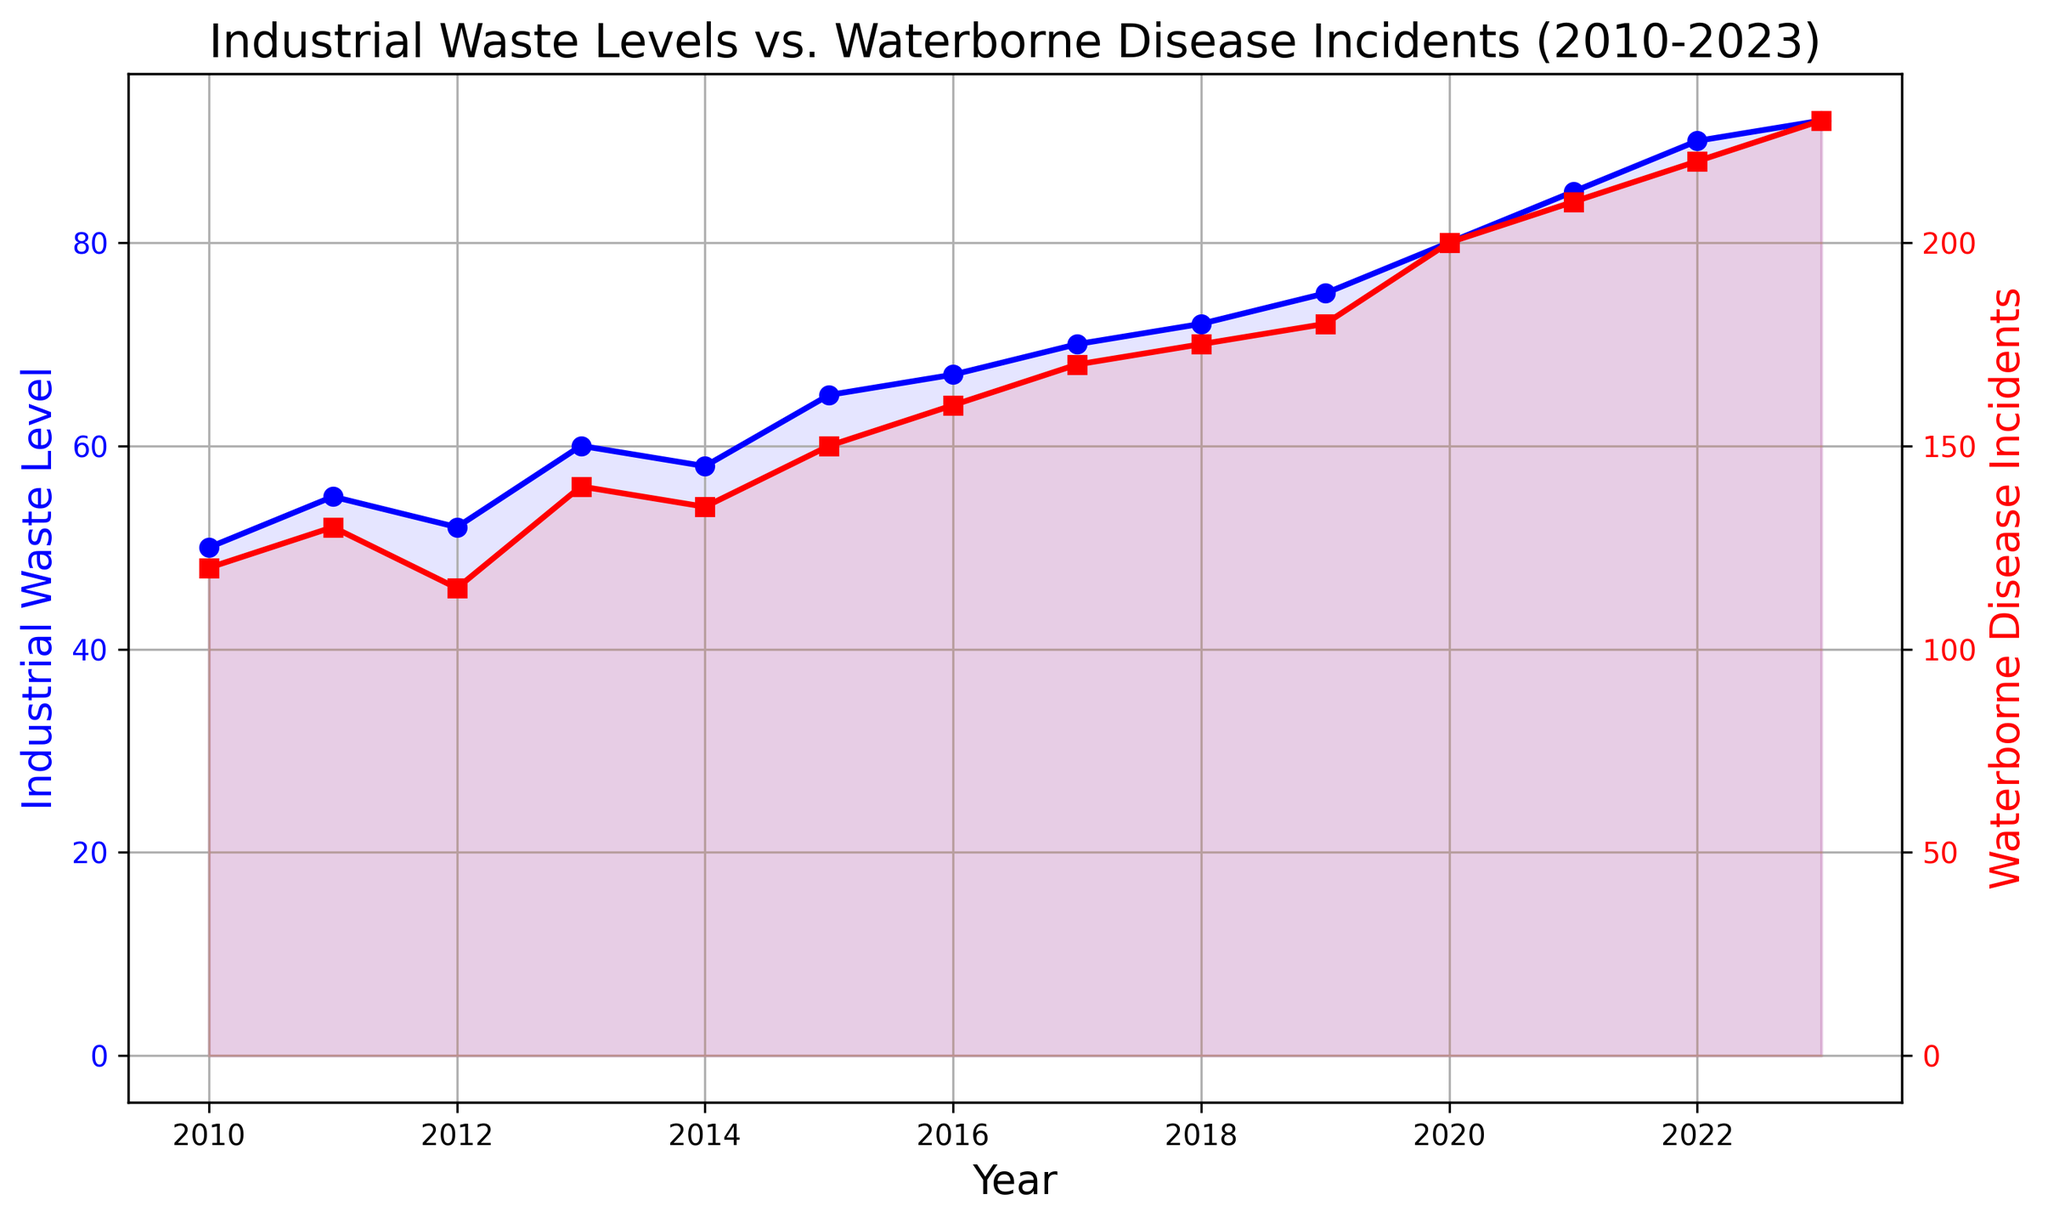What was the trend in the Industrial Waste Level between 2010 and 2023? The Industrial Waste Level shows a general increasing trend between 2010 and 2023, starting from 50 units in 2010 and ending at 92 units in 2023. The values increase almost every year with minor fluctuations.
Answer: Increasing trend Which year had the highest number of Waterborne Disease Incidents? The highest number of Waterborne Disease Incidents is observed in 2023 with 230 incidents. This can be seen at the endpoint of the red line.
Answer: 2023 Which years show a decrease in Industrial Waste Levels compared to the previous year? To find the years with decreased Industrial Waste Levels, we check for drops along the blue line. The only decrease occurs from 2011 (55) to 2012 (52) and from 2014 (58) to 2015 (65).
Answer: 2012 and 2014 What is the total increase in Industrial Waste Level from 2010 to 2023? The total increase is calculated by subtracting the 2010 level from the 2023 level: 92 - 50 = 42.
Answer: 42 units How does the trend in Waterborne Disease Incidents correlate with Industrial Waste Levels? Both lines (red for incidents and blue for waste) show a similar increasing trend over the years, indicating a positive correlation. As the waste level increases, the disease incidents also increase.
Answer: Positive correlation By how much did the Waterborne Disease Incidents increase from 2010 to 2023? The increase is calculated by subtracting the 2010 incidents from the 2023 incidents: 230 - 120 = 110.
Answer: 110 incidents During which year was the difference between Industrial Waste Level and Waterborne Disease Incidents the smallest? By visually inspecting the distance between blue and red lines, we notice that in 2012, the values are closest: 52 units (waste) and 115 incidents (disease). The difference is 115 - 52 = 63.
Answer: 2012 How many years had Waterborne Disease Incidents greater than 150? Observing the red line, the years 2016 through 2023 have incidents greater than 150. Counting these years from 2016 onward gives 8 years.
Answer: 8 years 